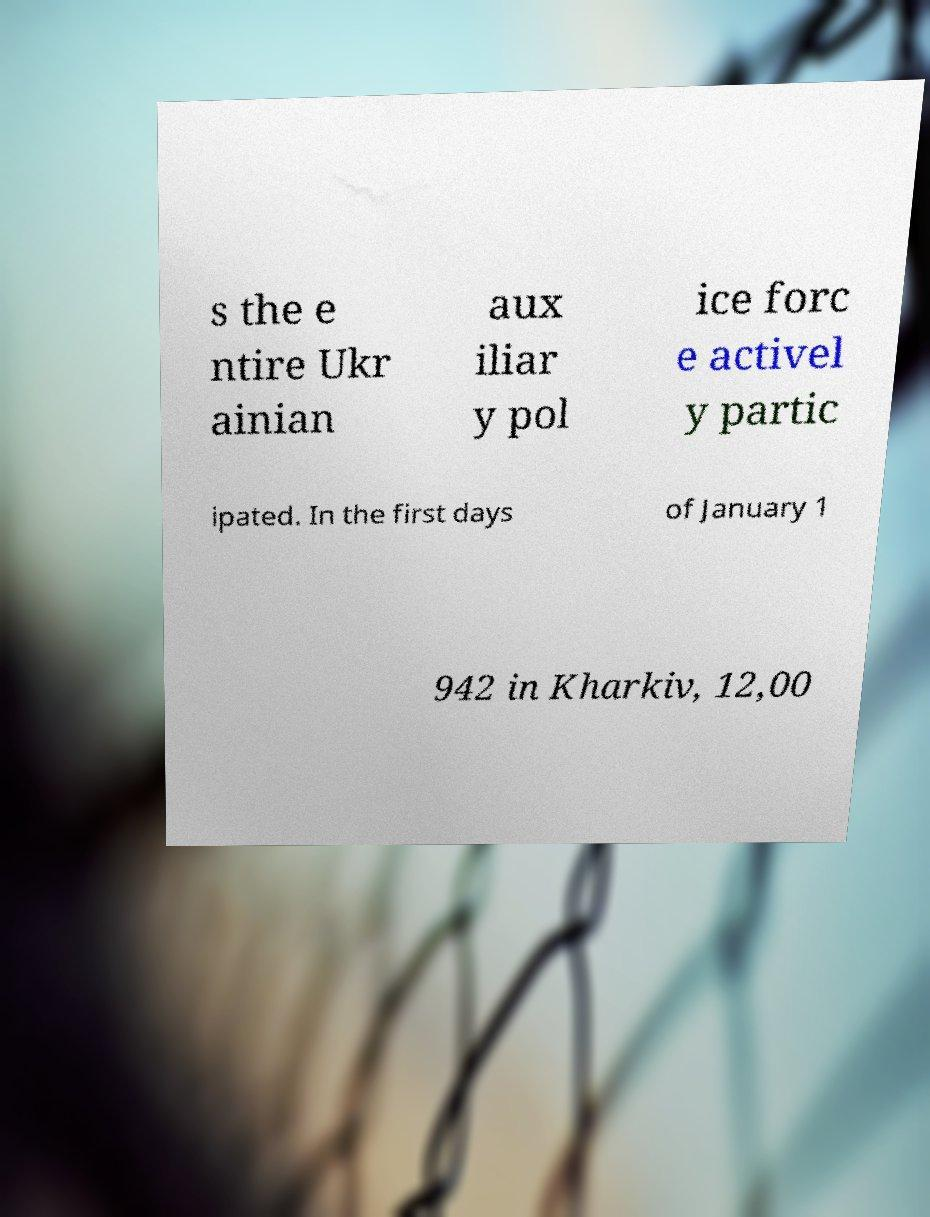There's text embedded in this image that I need extracted. Can you transcribe it verbatim? s the e ntire Ukr ainian aux iliar y pol ice forc e activel y partic ipated. In the first days of January 1 942 in Kharkiv, 12,00 